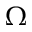Convert formula to latex. <formula><loc_0><loc_0><loc_500><loc_500>\Omega</formula> 